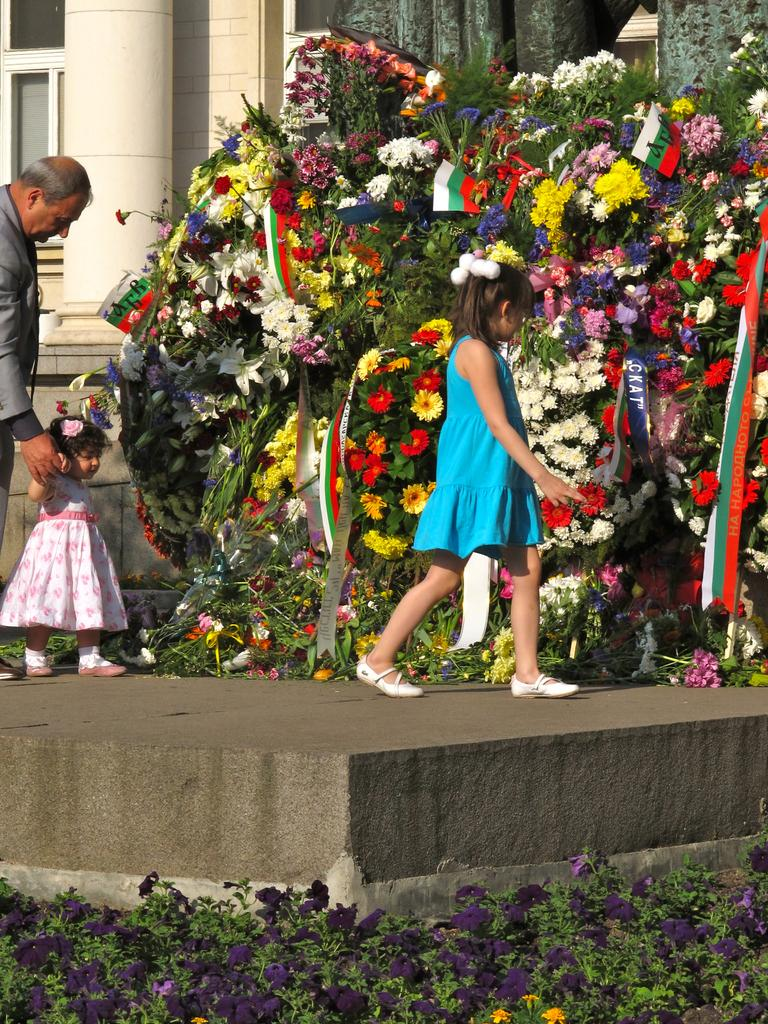What can be seen growing in the image? There are flowers in the image. What are the girls in the image doing? The girls are walking in the image. How is the man interacting with one of the girls? The man is holding a girl's hand in the image. What type of decorations are present in the image? There are flags in the image. What type of structures can be seen in the background? There are buildings in the image. What other type of flora can be seen on the ground in the image? There are plants with flowers on the ground in the image. What type of quiver is the man carrying in the image? There is no quiver present in the image. What kind of notebook is the girl holding in the image? There is no notebook present in the image. 